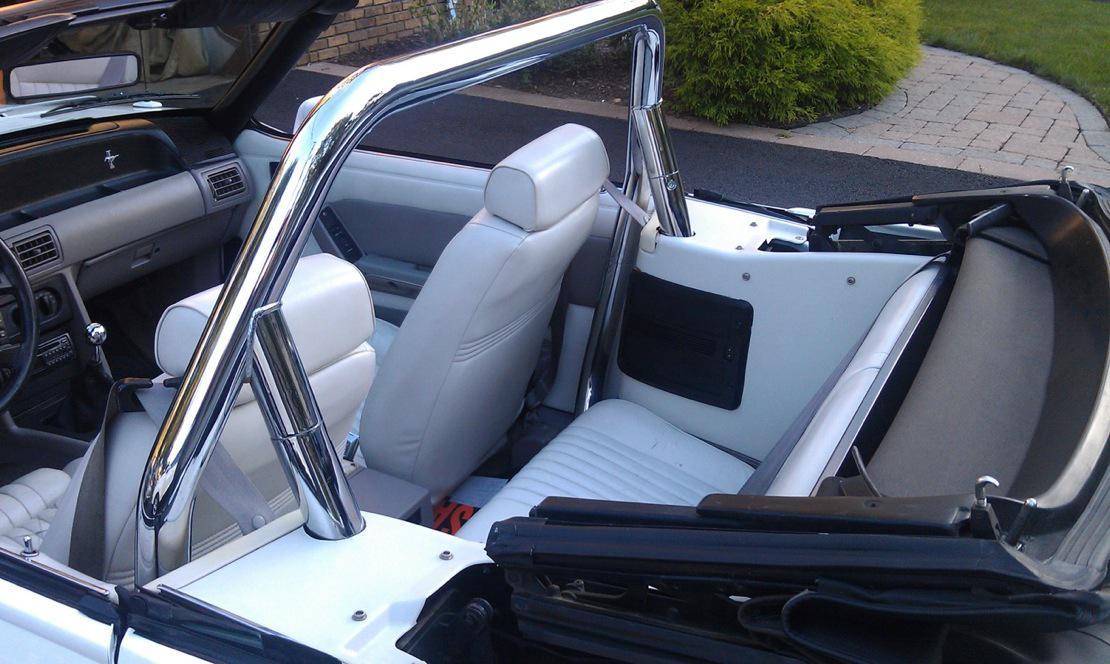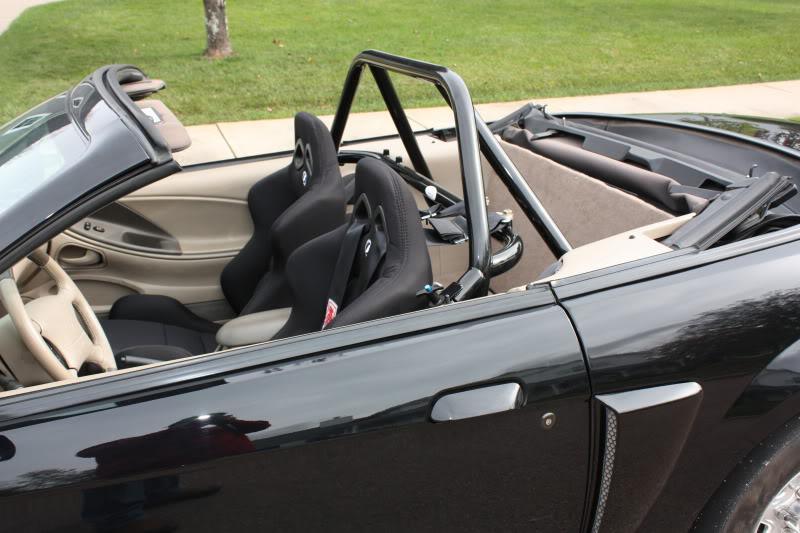The first image is the image on the left, the second image is the image on the right. Assess this claim about the two images: "A white car is parked on the road in one of the images.". Correct or not? Answer yes or no. No. The first image is the image on the left, the second image is the image on the right. Examine the images to the left and right. Is the description "An image shows a white topless convertible displayed parked at an angle on pavement." accurate? Answer yes or no. No. 